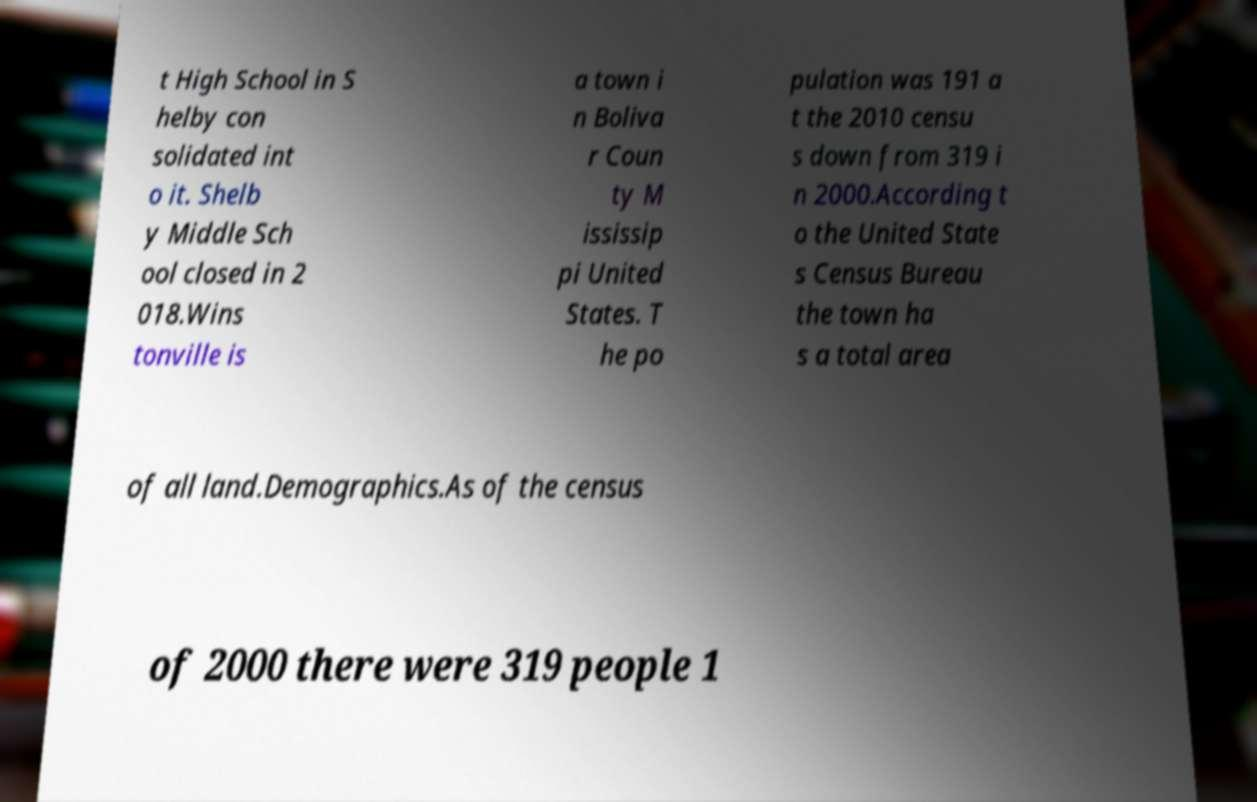For documentation purposes, I need the text within this image transcribed. Could you provide that? t High School in S helby con solidated int o it. Shelb y Middle Sch ool closed in 2 018.Wins tonville is a town i n Boliva r Coun ty M ississip pi United States. T he po pulation was 191 a t the 2010 censu s down from 319 i n 2000.According t o the United State s Census Bureau the town ha s a total area of all land.Demographics.As of the census of 2000 there were 319 people 1 